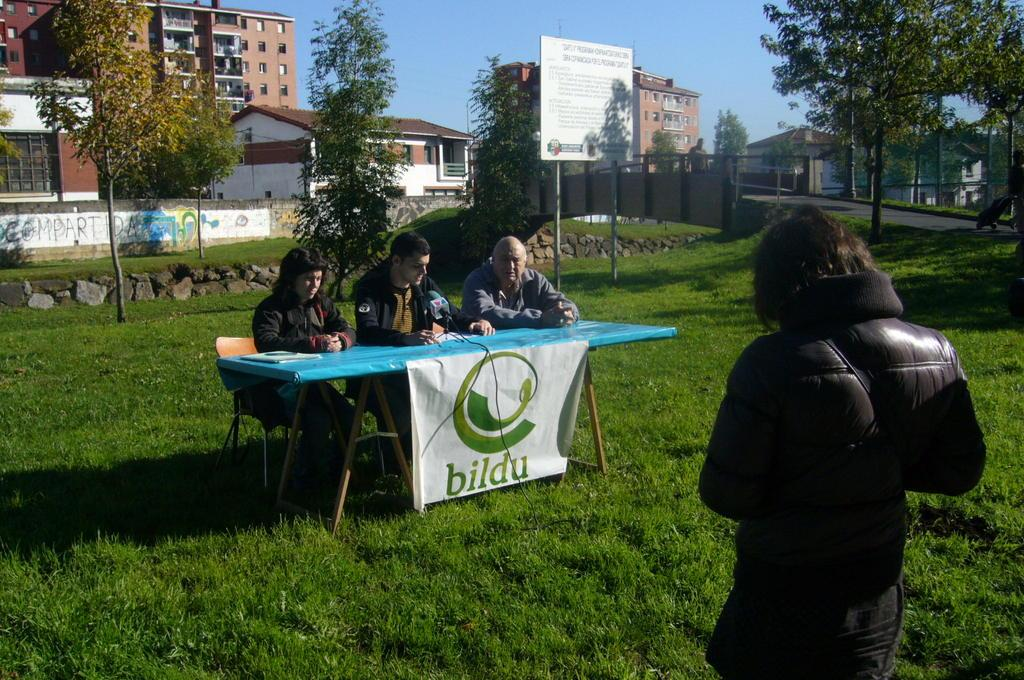Provide a one-sentence caption for the provided image. Three men are sitting at a table with a bildu banner. 